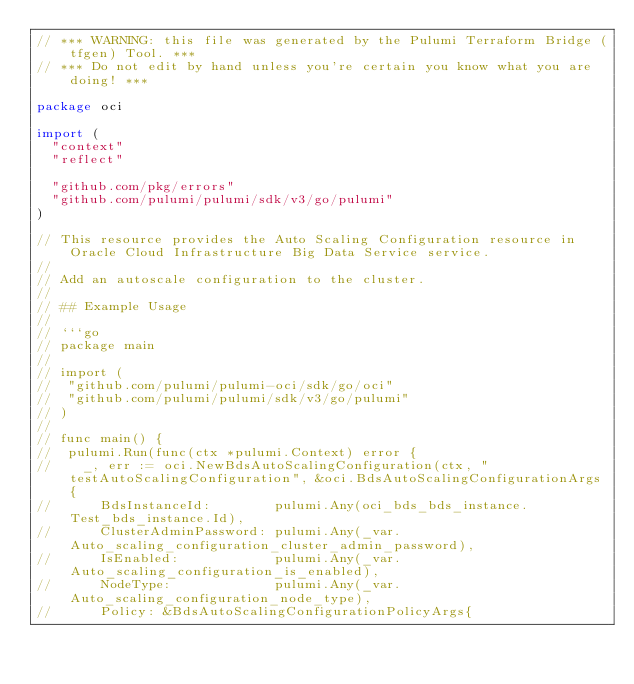<code> <loc_0><loc_0><loc_500><loc_500><_Go_>// *** WARNING: this file was generated by the Pulumi Terraform Bridge (tfgen) Tool. ***
// *** Do not edit by hand unless you're certain you know what you are doing! ***

package oci

import (
	"context"
	"reflect"

	"github.com/pkg/errors"
	"github.com/pulumi/pulumi/sdk/v3/go/pulumi"
)

// This resource provides the Auto Scaling Configuration resource in Oracle Cloud Infrastructure Big Data Service service.
//
// Add an autoscale configuration to the cluster.
//
// ## Example Usage
//
// ```go
// package main
//
// import (
// 	"github.com/pulumi/pulumi-oci/sdk/go/oci"
// 	"github.com/pulumi/pulumi/sdk/v3/go/pulumi"
// )
//
// func main() {
// 	pulumi.Run(func(ctx *pulumi.Context) error {
// 		_, err := oci.NewBdsAutoScalingConfiguration(ctx, "testAutoScalingConfiguration", &oci.BdsAutoScalingConfigurationArgs{
// 			BdsInstanceId:        pulumi.Any(oci_bds_bds_instance.Test_bds_instance.Id),
// 			ClusterAdminPassword: pulumi.Any(_var.Auto_scaling_configuration_cluster_admin_password),
// 			IsEnabled:            pulumi.Any(_var.Auto_scaling_configuration_is_enabled),
// 			NodeType:             pulumi.Any(_var.Auto_scaling_configuration_node_type),
// 			Policy: &BdsAutoScalingConfigurationPolicyArgs{</code> 